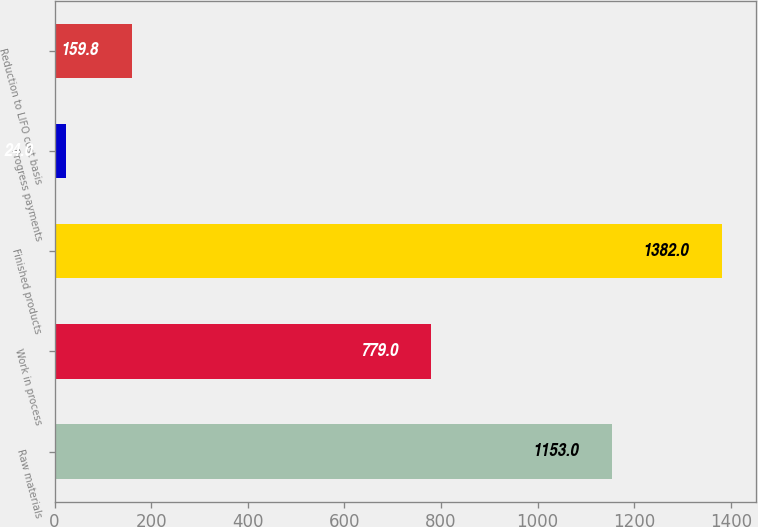Convert chart. <chart><loc_0><loc_0><loc_500><loc_500><bar_chart><fcel>Raw materials<fcel>Work in process<fcel>Finished products<fcel>Progress payments<fcel>Reduction to LIFO cost basis<nl><fcel>1153<fcel>779<fcel>1382<fcel>24<fcel>159.8<nl></chart> 